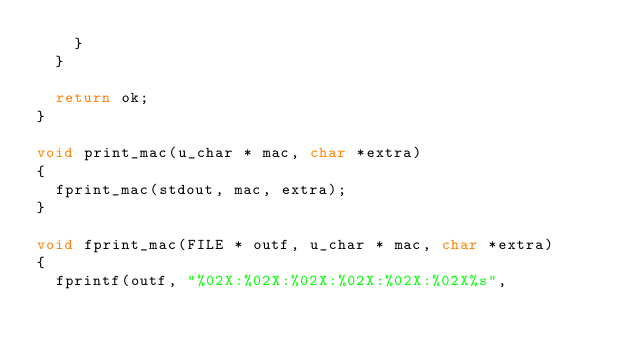<code> <loc_0><loc_0><loc_500><loc_500><_C_>		}
	}

	return ok;
}

void print_mac(u_char * mac, char *extra)
{
	fprint_mac(stdout, mac, extra);
}

void fprint_mac(FILE * outf, u_char * mac, char *extra)
{
	fprintf(outf, "%02X:%02X:%02X:%02X:%02X:%02X%s",</code> 